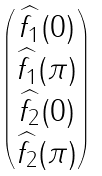Convert formula to latex. <formula><loc_0><loc_0><loc_500><loc_500>\begin{pmatrix} \widehat { f _ { 1 } } ( 0 ) \\ \widehat { f _ { 1 } } ( \pi ) \\ \widehat { f _ { 2 } } ( 0 ) \\ \widehat { f _ { 2 } } ( \pi ) \end{pmatrix}</formula> 